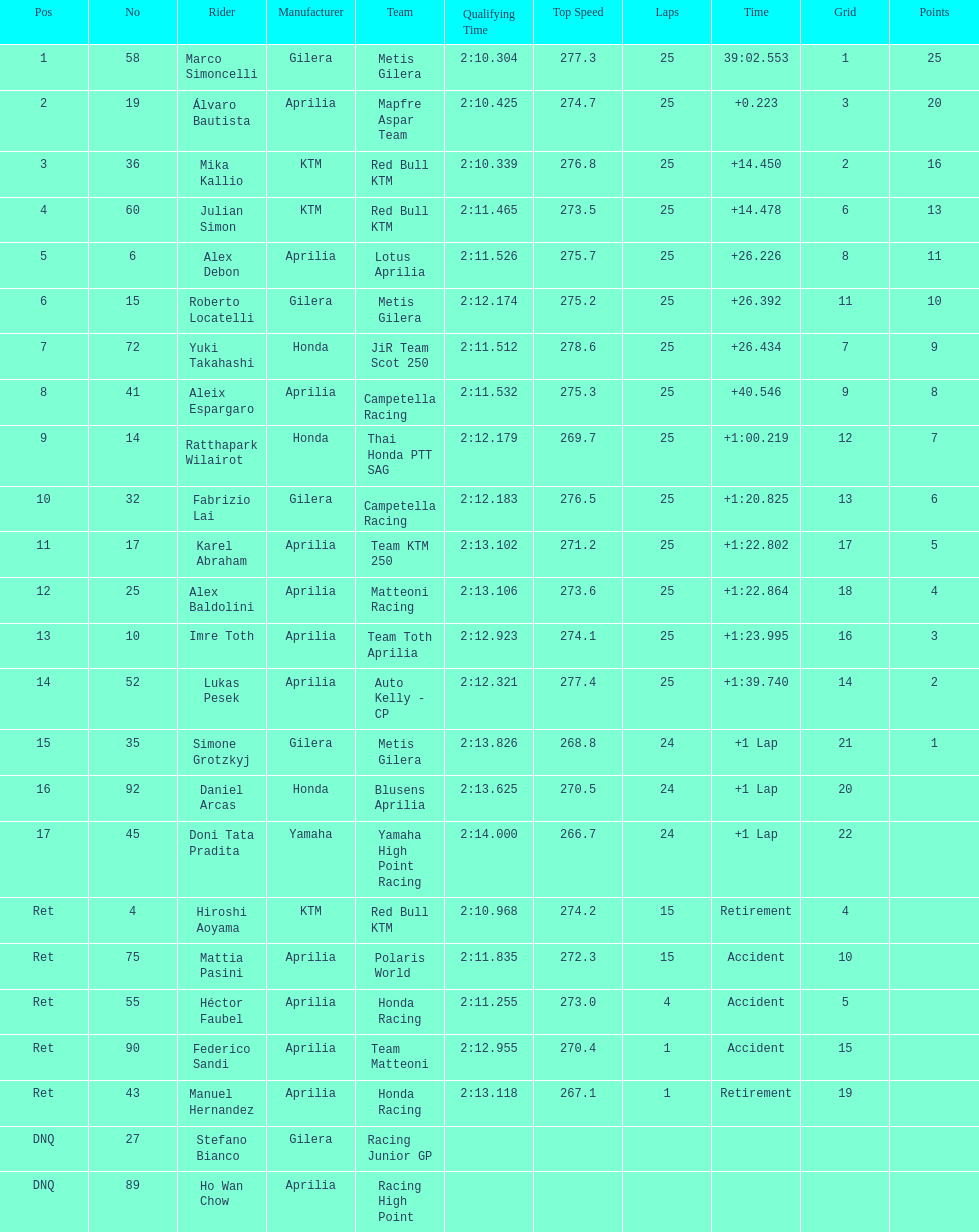Did marco simoncelli or alvaro bautista held rank 1? Marco Simoncelli. 